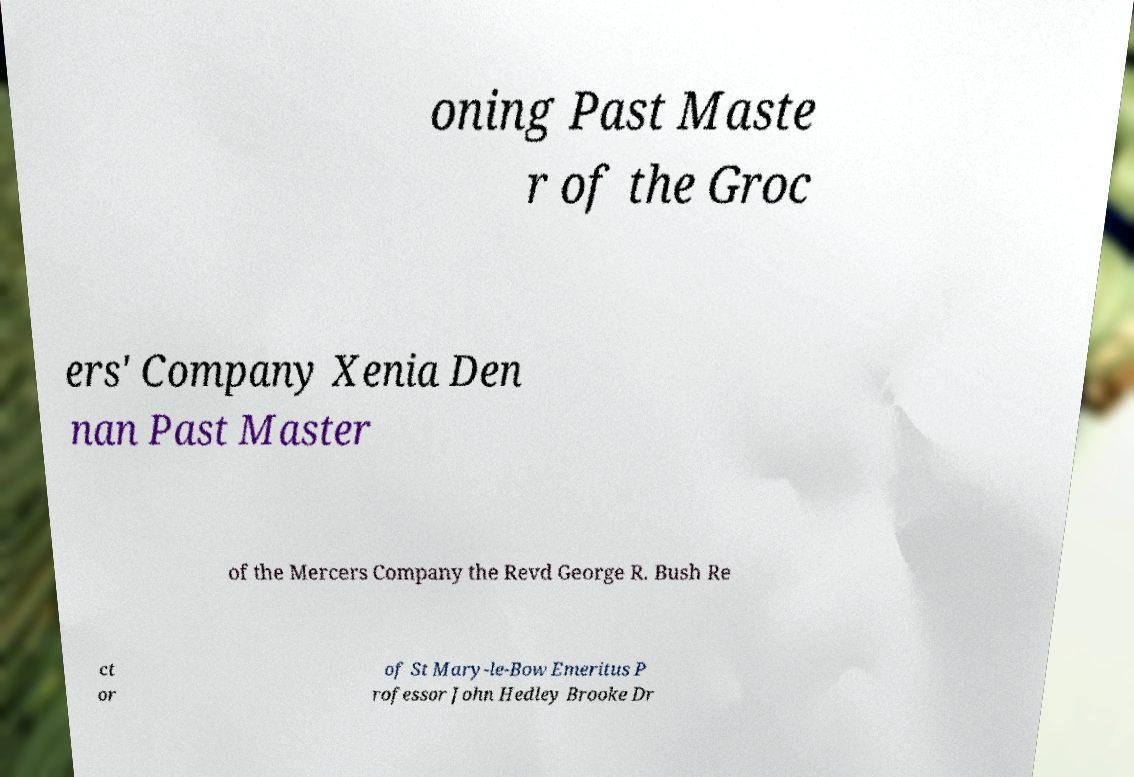I need the written content from this picture converted into text. Can you do that? oning Past Maste r of the Groc ers' Company Xenia Den nan Past Master of the Mercers Company the Revd George R. Bush Re ct or of St Mary-le-Bow Emeritus P rofessor John Hedley Brooke Dr 